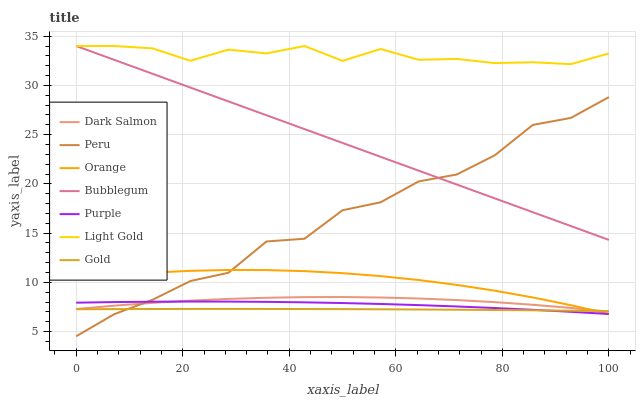Does Gold have the minimum area under the curve?
Answer yes or no. Yes. Does Light Gold have the maximum area under the curve?
Answer yes or no. Yes. Does Purple have the minimum area under the curve?
Answer yes or no. No. Does Purple have the maximum area under the curve?
Answer yes or no. No. Is Bubblegum the smoothest?
Answer yes or no. Yes. Is Peru the roughest?
Answer yes or no. Yes. Is Purple the smoothest?
Answer yes or no. No. Is Purple the roughest?
Answer yes or no. No. Does Peru have the lowest value?
Answer yes or no. Yes. Does Purple have the lowest value?
Answer yes or no. No. Does Light Gold have the highest value?
Answer yes or no. Yes. Does Purple have the highest value?
Answer yes or no. No. Is Gold less than Bubblegum?
Answer yes or no. Yes. Is Bubblegum greater than Purple?
Answer yes or no. Yes. Does Gold intersect Orange?
Answer yes or no. Yes. Is Gold less than Orange?
Answer yes or no. No. Is Gold greater than Orange?
Answer yes or no. No. Does Gold intersect Bubblegum?
Answer yes or no. No. 